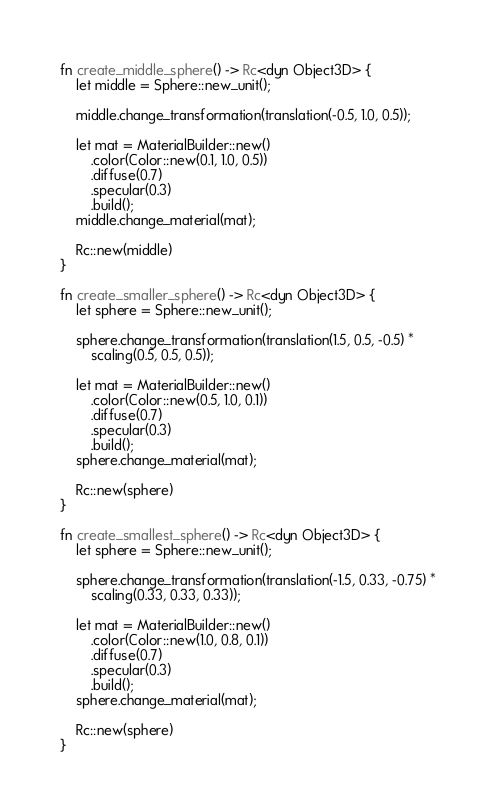Convert code to text. <code><loc_0><loc_0><loc_500><loc_500><_Rust_>fn create_middle_sphere() -> Rc<dyn Object3D> {
    let middle = Sphere::new_unit();

    middle.change_transformation(translation(-0.5, 1.0, 0.5));

    let mat = MaterialBuilder::new()
        .color(Color::new(0.1, 1.0, 0.5))
        .diffuse(0.7)
        .specular(0.3)
        .build();
    middle.change_material(mat);

    Rc::new(middle)
}

fn create_smaller_sphere() -> Rc<dyn Object3D> {
    let sphere = Sphere::new_unit();

    sphere.change_transformation(translation(1.5, 0.5, -0.5) *
        scaling(0.5, 0.5, 0.5));

    let mat = MaterialBuilder::new()
        .color(Color::new(0.5, 1.0, 0.1))
        .diffuse(0.7)
        .specular(0.3)
        .build();
    sphere.change_material(mat);

    Rc::new(sphere)
}

fn create_smallest_sphere() -> Rc<dyn Object3D> {
    let sphere = Sphere::new_unit();

    sphere.change_transformation(translation(-1.5, 0.33, -0.75) *
        scaling(0.33, 0.33, 0.33));

    let mat = MaterialBuilder::new()
        .color(Color::new(1.0, 0.8, 0.1))
        .diffuse(0.7)
        .specular(0.3)
        .build();
    sphere.change_material(mat);

    Rc::new(sphere)
}</code> 